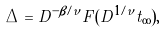Convert formula to latex. <formula><loc_0><loc_0><loc_500><loc_500>\Delta = D ^ { - \beta / \nu } F ( D ^ { 1 / \nu } t _ { \infty } ) ,</formula> 